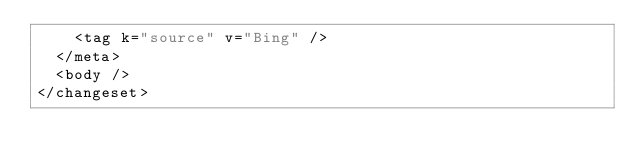<code> <loc_0><loc_0><loc_500><loc_500><_XML_>    <tag k="source" v="Bing" />
  </meta>
  <body />
</changeset>
</code> 